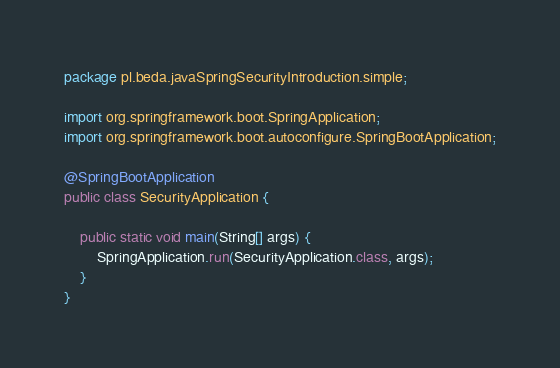Convert code to text. <code><loc_0><loc_0><loc_500><loc_500><_Java_>package pl.beda.javaSpringSecurityIntroduction.simple;

import org.springframework.boot.SpringApplication;
import org.springframework.boot.autoconfigure.SpringBootApplication;

@SpringBootApplication
public class SecurityApplication {

    public static void main(String[] args) {
        SpringApplication.run(SecurityApplication.class, args);
    }
}
</code> 